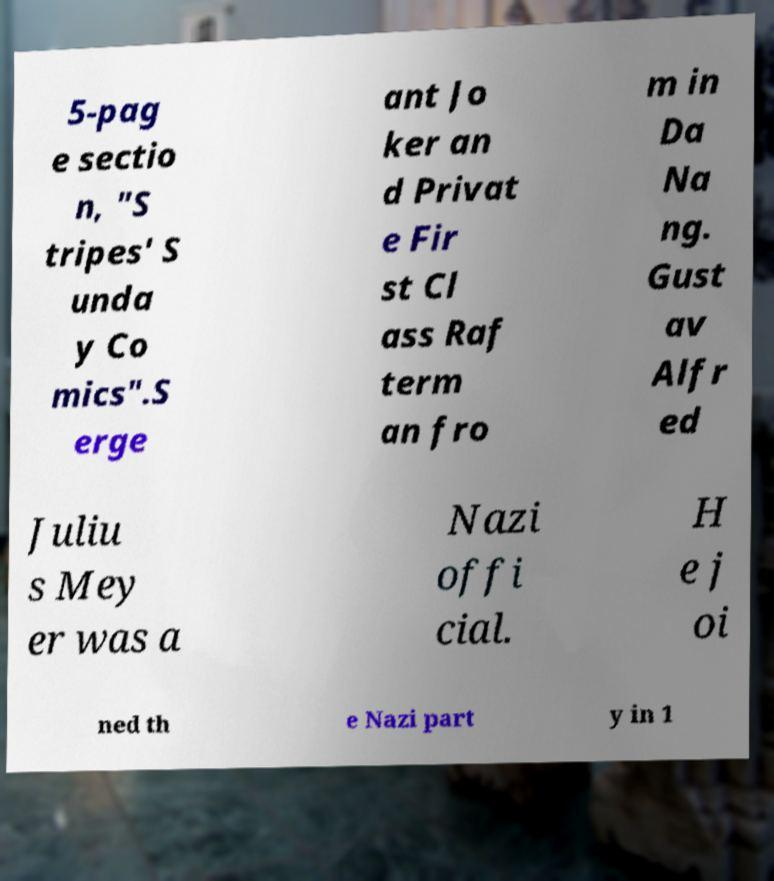Please identify and transcribe the text found in this image. 5-pag e sectio n, "S tripes' S unda y Co mics".S erge ant Jo ker an d Privat e Fir st Cl ass Raf term an fro m in Da Na ng. Gust av Alfr ed Juliu s Mey er was a Nazi offi cial. H e j oi ned th e Nazi part y in 1 